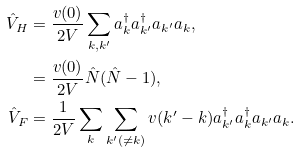<formula> <loc_0><loc_0><loc_500><loc_500>\hat { V } _ { H } & = \frac { v ( { 0 } ) } { 2 V } \sum _ { k , k ^ { \prime } } a _ { k } ^ { \dagger } a _ { k ^ { \prime } } ^ { \dagger } a _ { k ^ { \prime } } a _ { k } , \\ & = \frac { v ( { 0 } ) } { 2 V } \hat { N } ( \hat { N } - 1 ) , \\ \hat { V } _ { F } & = \frac { 1 } { 2 V } \sum _ { k } \sum _ { k ^ { \prime } ( \neq k ) } v ( { k } ^ { \prime } - { k } ) a _ { k ^ { \prime } } ^ { \dagger } a _ { k } ^ { \dagger } a _ { k ^ { \prime } } a _ { k } .</formula> 